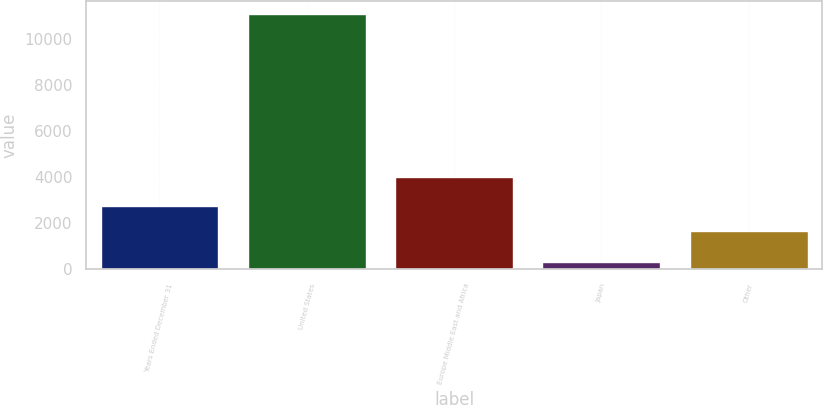Convert chart. <chart><loc_0><loc_0><loc_500><loc_500><bar_chart><fcel>Years Ended December 31<fcel>United States<fcel>Europe Middle East and Africa<fcel>Japan<fcel>Other<nl><fcel>2751.3<fcel>11078<fcel>4014<fcel>315<fcel>1675<nl></chart> 